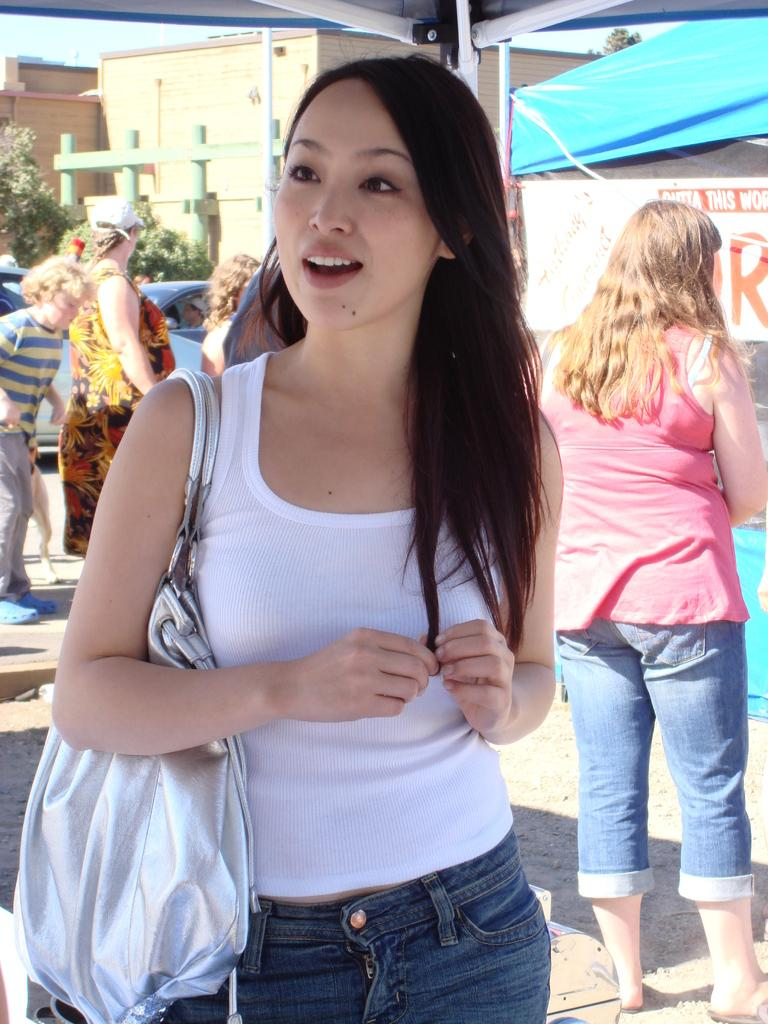What is the setting of the image? The image is an outside view. What can be seen in the image besides the outdoor setting? There is a group of people standing in the image. What are the people wearing? The people are wearing clothes. What structure is visible in the image? There is a building visible at the top of the image. Can you tell me how many family members are wearing a veil in the image? There is no family or veil present in the image. What type of control is being exercised by the people in the image? There is no indication of control or any related activity in the image. 